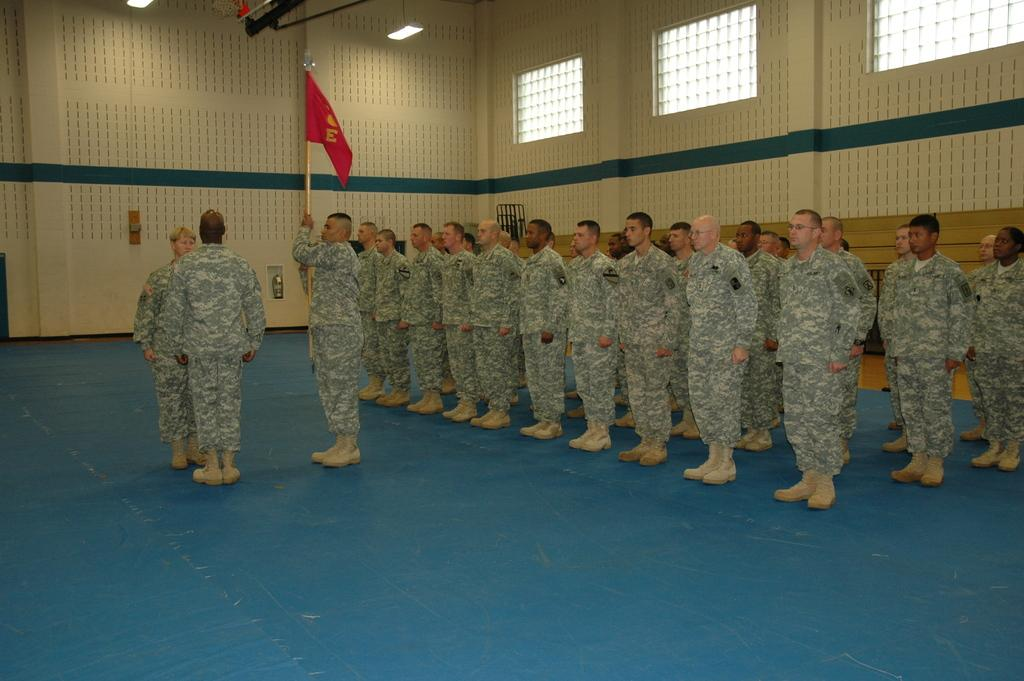How many people are in the image? There is a group of people in the image. Can you describe the man in the middle of the image? The man in the middle of the image is holding a flag. What can be seen at the top of the image? There are lights visible at the top of the image. Are there any fairies flying around the man holding the flag in the image? No, there are no fairies present in the image. Can you describe the ants crawling on the flag in the image? There are no ants visible on the flag in the image. 